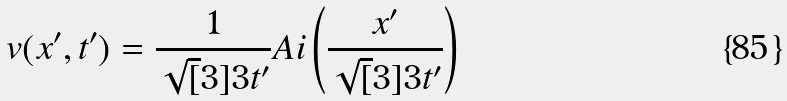<formula> <loc_0><loc_0><loc_500><loc_500>v ( x ^ { \prime } , t ^ { \prime } ) = \frac { 1 } { \sqrt { [ } 3 ] { 3 t ^ { \prime } } } A i \left ( \frac { x ^ { \prime } } { \sqrt { [ } 3 ] { 3 t ^ { \prime } } } \right )</formula> 